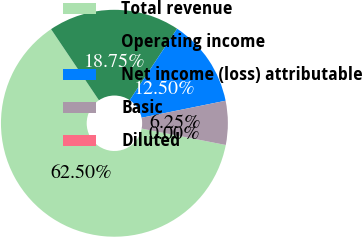Convert chart to OTSL. <chart><loc_0><loc_0><loc_500><loc_500><pie_chart><fcel>Total revenue<fcel>Operating income<fcel>Net income (loss) attributable<fcel>Basic<fcel>Diluted<nl><fcel>62.5%<fcel>18.75%<fcel>12.5%<fcel>6.25%<fcel>0.0%<nl></chart> 